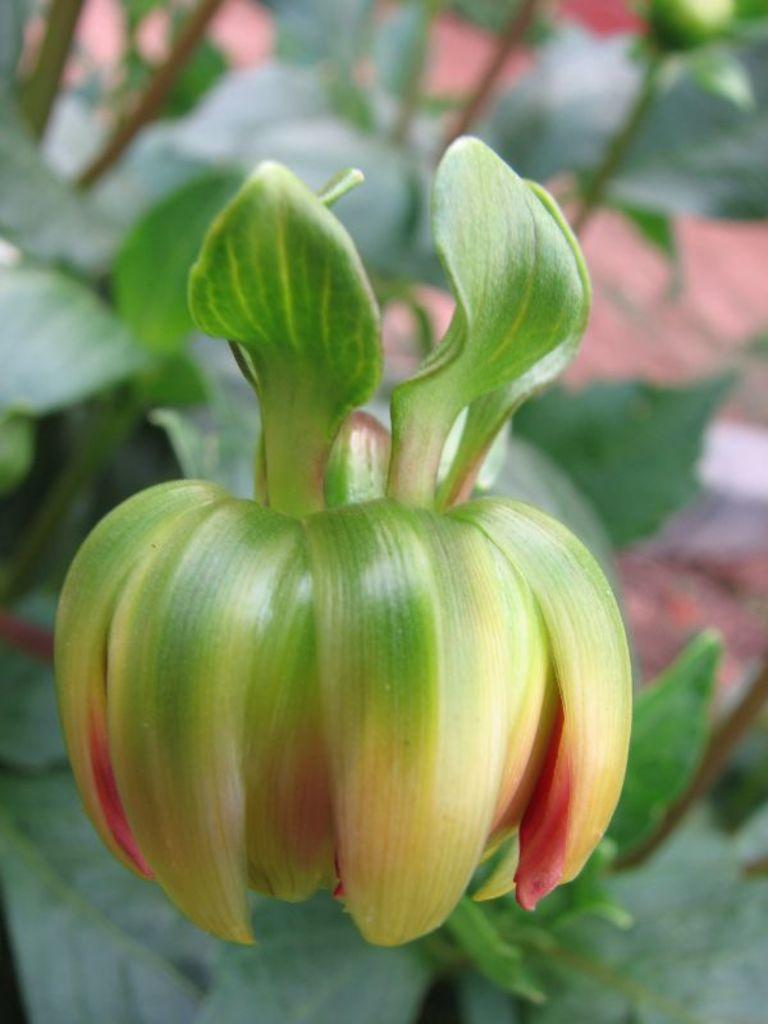What is the main subject of the image? There is a flower in the image. What else can be seen in the image besides the flower? There are leaves in the image. How would you describe the background of the image? The background of the image is blurred. What is the opinion of the ear in the image? There is no ear present in the image, so it is not possible to determine its opinion. 